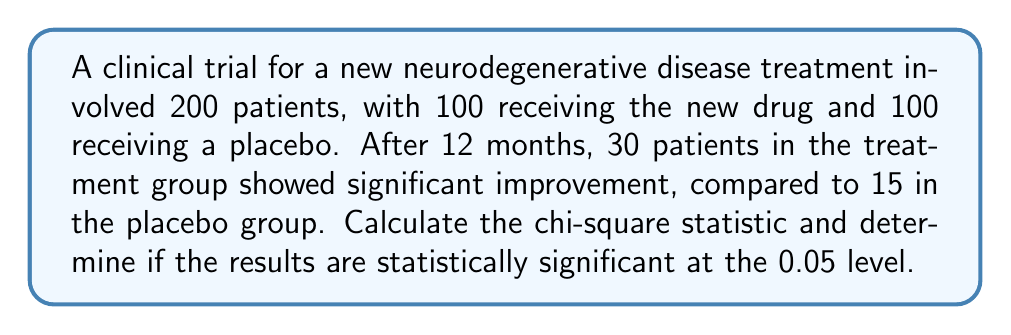Could you help me with this problem? To analyze the statistical significance of these clinical trial results, we'll use the chi-square test of independence.

Step 1: Set up the contingency table
| Group     | Improved | Not Improved | Total |
|-----------|----------|--------------|-------|
| Treatment | 30       | 70           | 100   |
| Placebo   | 15       | 85           | 100   |
| Total     | 45       | 155          | 200   |

Step 2: Calculate expected frequencies
For each cell: $E = \frac{\text{row total} \times \text{column total}}{\text{grand total}}$

$E_{11} = \frac{100 \times 45}{200} = 22.5$
$E_{12} = \frac{100 \times 155}{200} = 77.5$
$E_{21} = \frac{100 \times 45}{200} = 22.5$
$E_{22} = \frac{100 \times 155}{200} = 77.5$

Step 3: Calculate the chi-square statistic
$$\chi^2 = \sum\frac{(O - E)^2}{E}$$

$\chi^2 = \frac{(30 - 22.5)^2}{22.5} + \frac{(70 - 77.5)^2}{77.5} + \frac{(15 - 22.5)^2}{22.5} + \frac{(85 - 77.5)^2}{77.5}$

$\chi^2 = 2.5 + 0.73 + 2.5 + 0.73 = 6.46$

Step 4: Determine degrees of freedom
$df = (r-1)(c-1) = (2-1)(2-1) = 1$

Step 5: Compare to critical value
For $\alpha = 0.05$ and $df = 1$, the critical value is 3.841.

Since $6.46 > 3.841$, we reject the null hypothesis.
Answer: $\chi^2 = 6.46$; statistically significant 